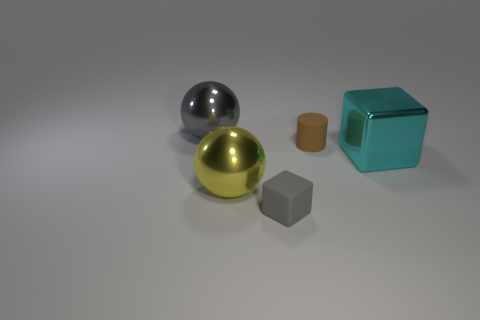There is a matte cylinder that is the same size as the gray matte cube; what is its color?
Your answer should be compact. Brown. Do the big gray ball and the brown cylinder have the same material?
Make the answer very short. No. How many big balls are the same color as the small rubber block?
Your answer should be very brief. 1. Is the color of the big block the same as the small block?
Ensure brevity in your answer.  No. There is a ball that is in front of the cylinder; what material is it?
Keep it short and to the point. Metal. What number of small things are either gray balls or purple cubes?
Your response must be concise. 0. There is a big sphere that is the same color as the small cube; what is it made of?
Your answer should be very brief. Metal. Is there a large block that has the same material as the tiny brown thing?
Your response must be concise. No. There is a matte thing behind the gray rubber block; does it have the same size as the cyan cube?
Provide a succinct answer. No. Are there any big cyan objects that are behind the gray thing that is in front of the gray object that is behind the small gray rubber object?
Your answer should be very brief. Yes. 